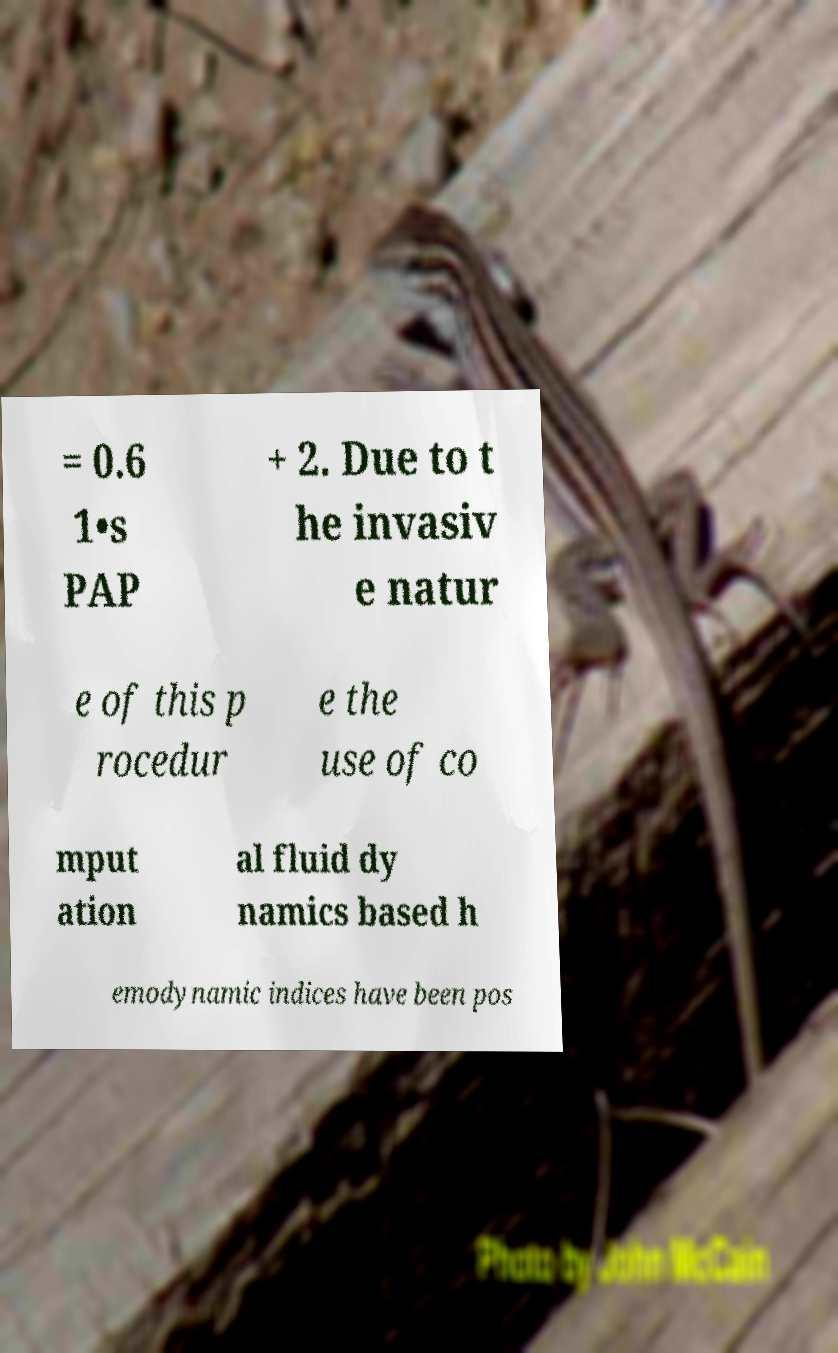Could you assist in decoding the text presented in this image and type it out clearly? = 0.6 1•s PAP + 2. Due to t he invasiv e natur e of this p rocedur e the use of co mput ation al fluid dy namics based h emodynamic indices have been pos 